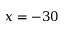<formula> <loc_0><loc_0><loc_500><loc_500>x = - 3 0</formula> 